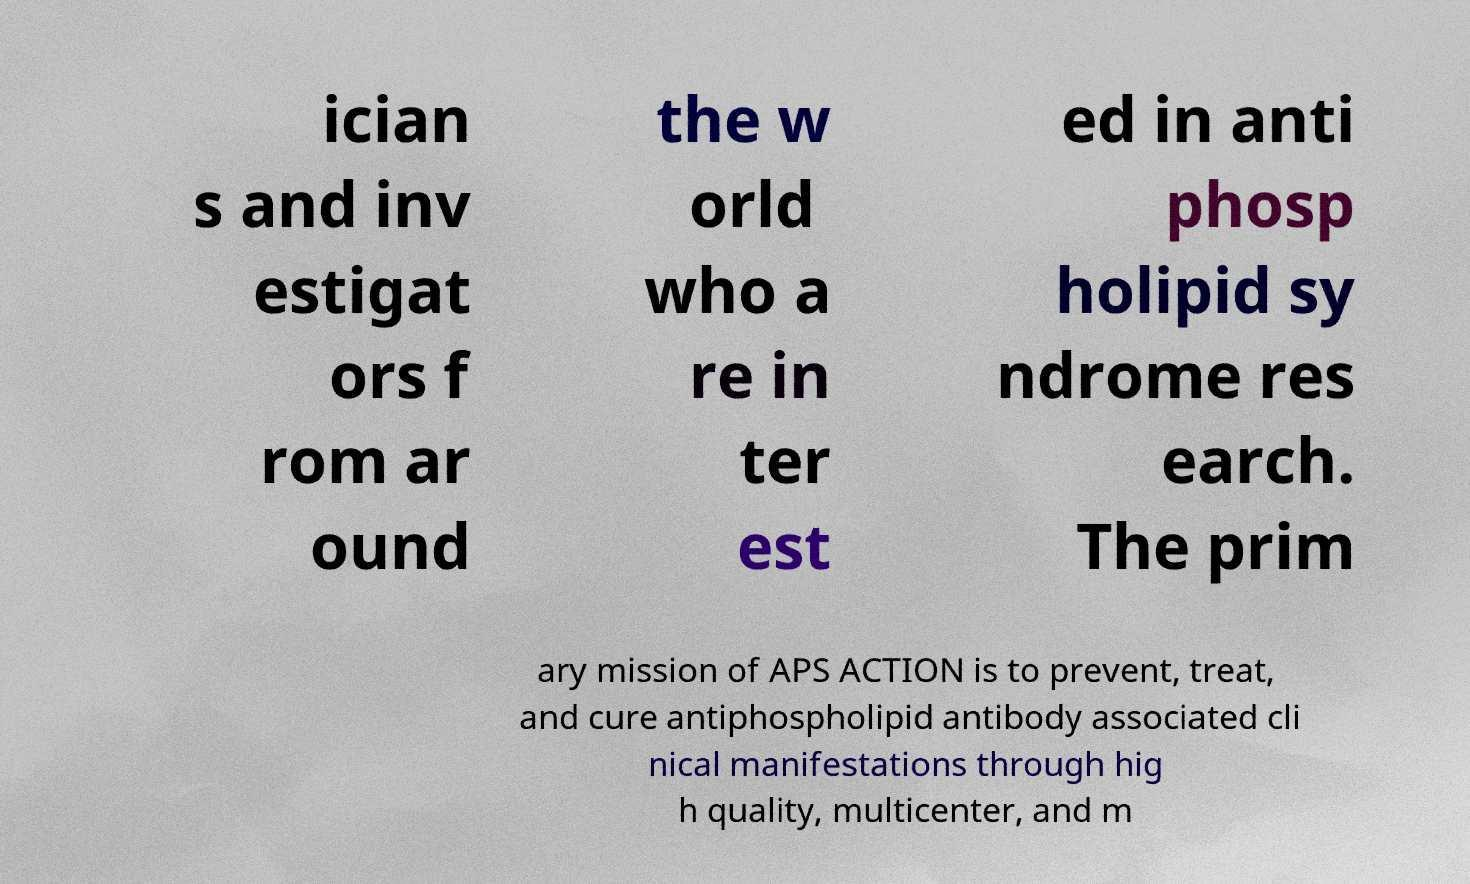For documentation purposes, I need the text within this image transcribed. Could you provide that? ician s and inv estigat ors f rom ar ound the w orld who a re in ter est ed in anti phosp holipid sy ndrome res earch. The prim ary mission of APS ACTION is to prevent, treat, and cure antiphospholipid antibody associated cli nical manifestations through hig h quality, multicenter, and m 